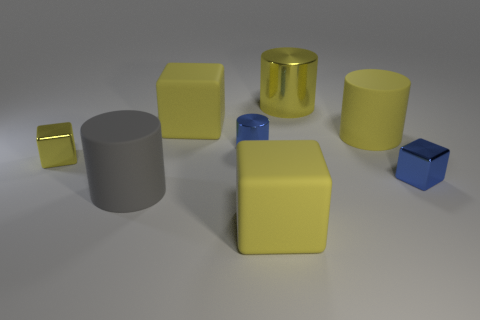How many yellow cubes must be subtracted to get 1 yellow cubes? 2 Subtract all blue metal cylinders. How many cylinders are left? 3 Add 2 tiny metal things. How many objects exist? 10 Subtract all purple blocks. How many yellow cylinders are left? 2 Subtract all yellow blocks. How many blocks are left? 1 Subtract 2 cylinders. How many cylinders are left? 2 Add 8 blue metallic objects. How many blue metallic objects are left? 10 Add 5 large yellow objects. How many large yellow objects exist? 9 Subtract 0 gray spheres. How many objects are left? 8 Subtract all blue blocks. Subtract all brown cylinders. How many blocks are left? 3 